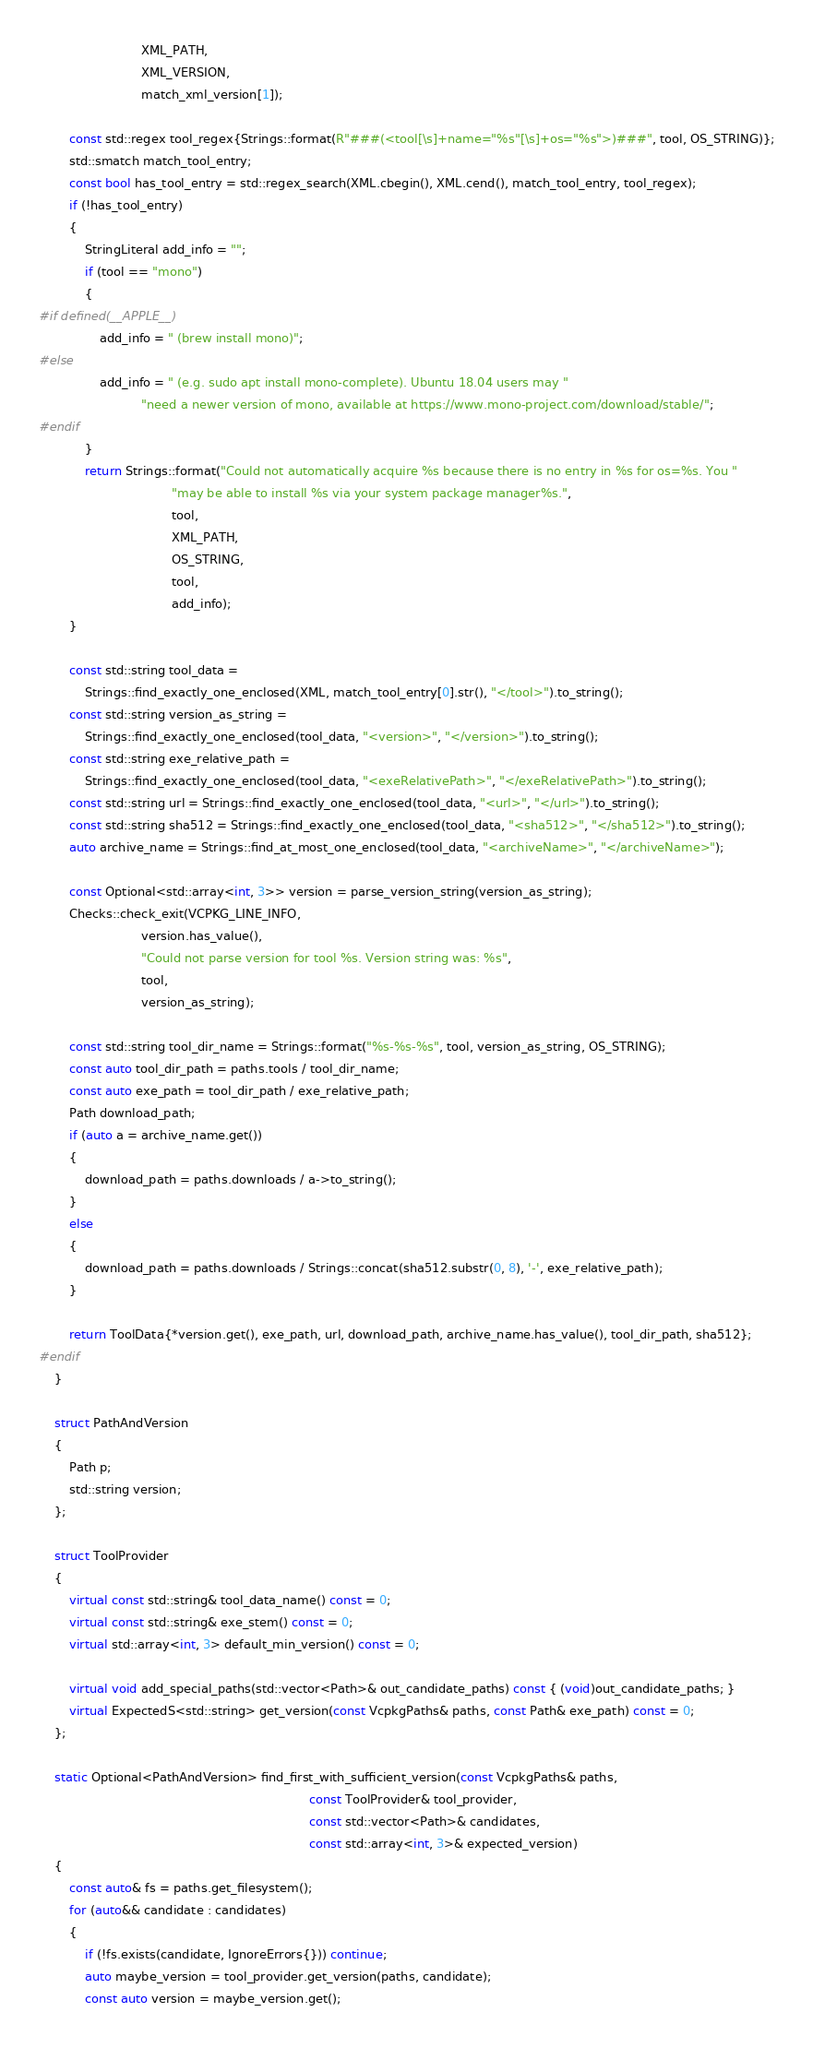Convert code to text. <code><loc_0><loc_0><loc_500><loc_500><_C++_>                           XML_PATH,
                           XML_VERSION,
                           match_xml_version[1]);

        const std::regex tool_regex{Strings::format(R"###(<tool[\s]+name="%s"[\s]+os="%s">)###", tool, OS_STRING)};
        std::smatch match_tool_entry;
        const bool has_tool_entry = std::regex_search(XML.cbegin(), XML.cend(), match_tool_entry, tool_regex);
        if (!has_tool_entry)
        {
            StringLiteral add_info = "";
            if (tool == "mono")
            {
#if defined(__APPLE__)
                add_info = " (brew install mono)";
#else
                add_info = " (e.g. sudo apt install mono-complete). Ubuntu 18.04 users may "
                           "need a newer version of mono, available at https://www.mono-project.com/download/stable/";
#endif
            }
            return Strings::format("Could not automatically acquire %s because there is no entry in %s for os=%s. You "
                                   "may be able to install %s via your system package manager%s.",
                                   tool,
                                   XML_PATH,
                                   OS_STRING,
                                   tool,
                                   add_info);
        }

        const std::string tool_data =
            Strings::find_exactly_one_enclosed(XML, match_tool_entry[0].str(), "</tool>").to_string();
        const std::string version_as_string =
            Strings::find_exactly_one_enclosed(tool_data, "<version>", "</version>").to_string();
        const std::string exe_relative_path =
            Strings::find_exactly_one_enclosed(tool_data, "<exeRelativePath>", "</exeRelativePath>").to_string();
        const std::string url = Strings::find_exactly_one_enclosed(tool_data, "<url>", "</url>").to_string();
        const std::string sha512 = Strings::find_exactly_one_enclosed(tool_data, "<sha512>", "</sha512>").to_string();
        auto archive_name = Strings::find_at_most_one_enclosed(tool_data, "<archiveName>", "</archiveName>");

        const Optional<std::array<int, 3>> version = parse_version_string(version_as_string);
        Checks::check_exit(VCPKG_LINE_INFO,
                           version.has_value(),
                           "Could not parse version for tool %s. Version string was: %s",
                           tool,
                           version_as_string);

        const std::string tool_dir_name = Strings::format("%s-%s-%s", tool, version_as_string, OS_STRING);
        const auto tool_dir_path = paths.tools / tool_dir_name;
        const auto exe_path = tool_dir_path / exe_relative_path;
        Path download_path;
        if (auto a = archive_name.get())
        {
            download_path = paths.downloads / a->to_string();
        }
        else
        {
            download_path = paths.downloads / Strings::concat(sha512.substr(0, 8), '-', exe_relative_path);
        }

        return ToolData{*version.get(), exe_path, url, download_path, archive_name.has_value(), tool_dir_path, sha512};
#endif
    }

    struct PathAndVersion
    {
        Path p;
        std::string version;
    };

    struct ToolProvider
    {
        virtual const std::string& tool_data_name() const = 0;
        virtual const std::string& exe_stem() const = 0;
        virtual std::array<int, 3> default_min_version() const = 0;

        virtual void add_special_paths(std::vector<Path>& out_candidate_paths) const { (void)out_candidate_paths; }
        virtual ExpectedS<std::string> get_version(const VcpkgPaths& paths, const Path& exe_path) const = 0;
    };

    static Optional<PathAndVersion> find_first_with_sufficient_version(const VcpkgPaths& paths,
                                                                       const ToolProvider& tool_provider,
                                                                       const std::vector<Path>& candidates,
                                                                       const std::array<int, 3>& expected_version)
    {
        const auto& fs = paths.get_filesystem();
        for (auto&& candidate : candidates)
        {
            if (!fs.exists(candidate, IgnoreErrors{})) continue;
            auto maybe_version = tool_provider.get_version(paths, candidate);
            const auto version = maybe_version.get();</code> 